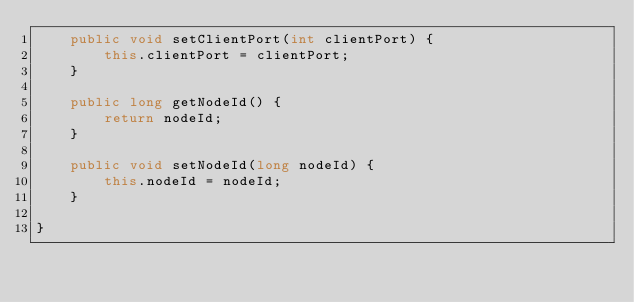<code> <loc_0><loc_0><loc_500><loc_500><_Java_>	public void setClientPort(int clientPort) {
		this.clientPort = clientPort;
	}

	public long getNodeId() {
		return nodeId;
	}

	public void setNodeId(long nodeId) {
		this.nodeId = nodeId;
	}

}
</code> 